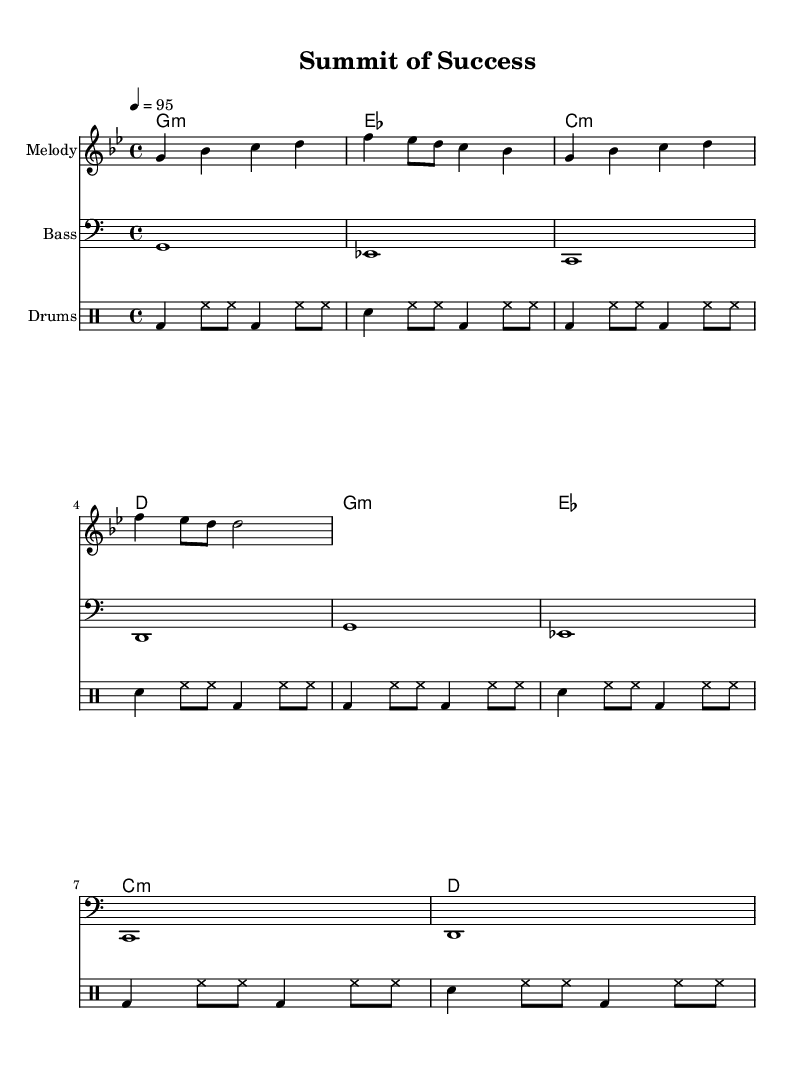What is the key signature of this music? The key signature is G minor, as indicated by the two flats on the staff.
Answer: G minor What is the time signature of this music? The time signature is indicated at the beginning of the piece, showing four beats in each measure.
Answer: 4/4 What is the tempo marking of this piece? The tempo marking indicates a speed of 95 beats per minute, showing how fast the music should be played.
Answer: 95 How many measures are there in the melody section? By counting the measures in the melody part, we see there are a total of four measures present.
Answer: 4 What is the first chord played in the chord progression? The first chord written in the chord progression is G minor, showing what harmonies accompany the melody at the start.
Answer: G minor Which instruments are featured in this sheet music? The sheet music features a Melody staff, a Bass staff, and a Drum staff, indicating the different parts in the performance.
Answer: Melody, Bass, Drums What rhythmic elements are used in the drum patterns? The drum patterns include bass drums, snare drums, and hi-hats, showcasing the components typical to hip-hop beats.
Answer: Bass drum, snare drum, hi-hat 